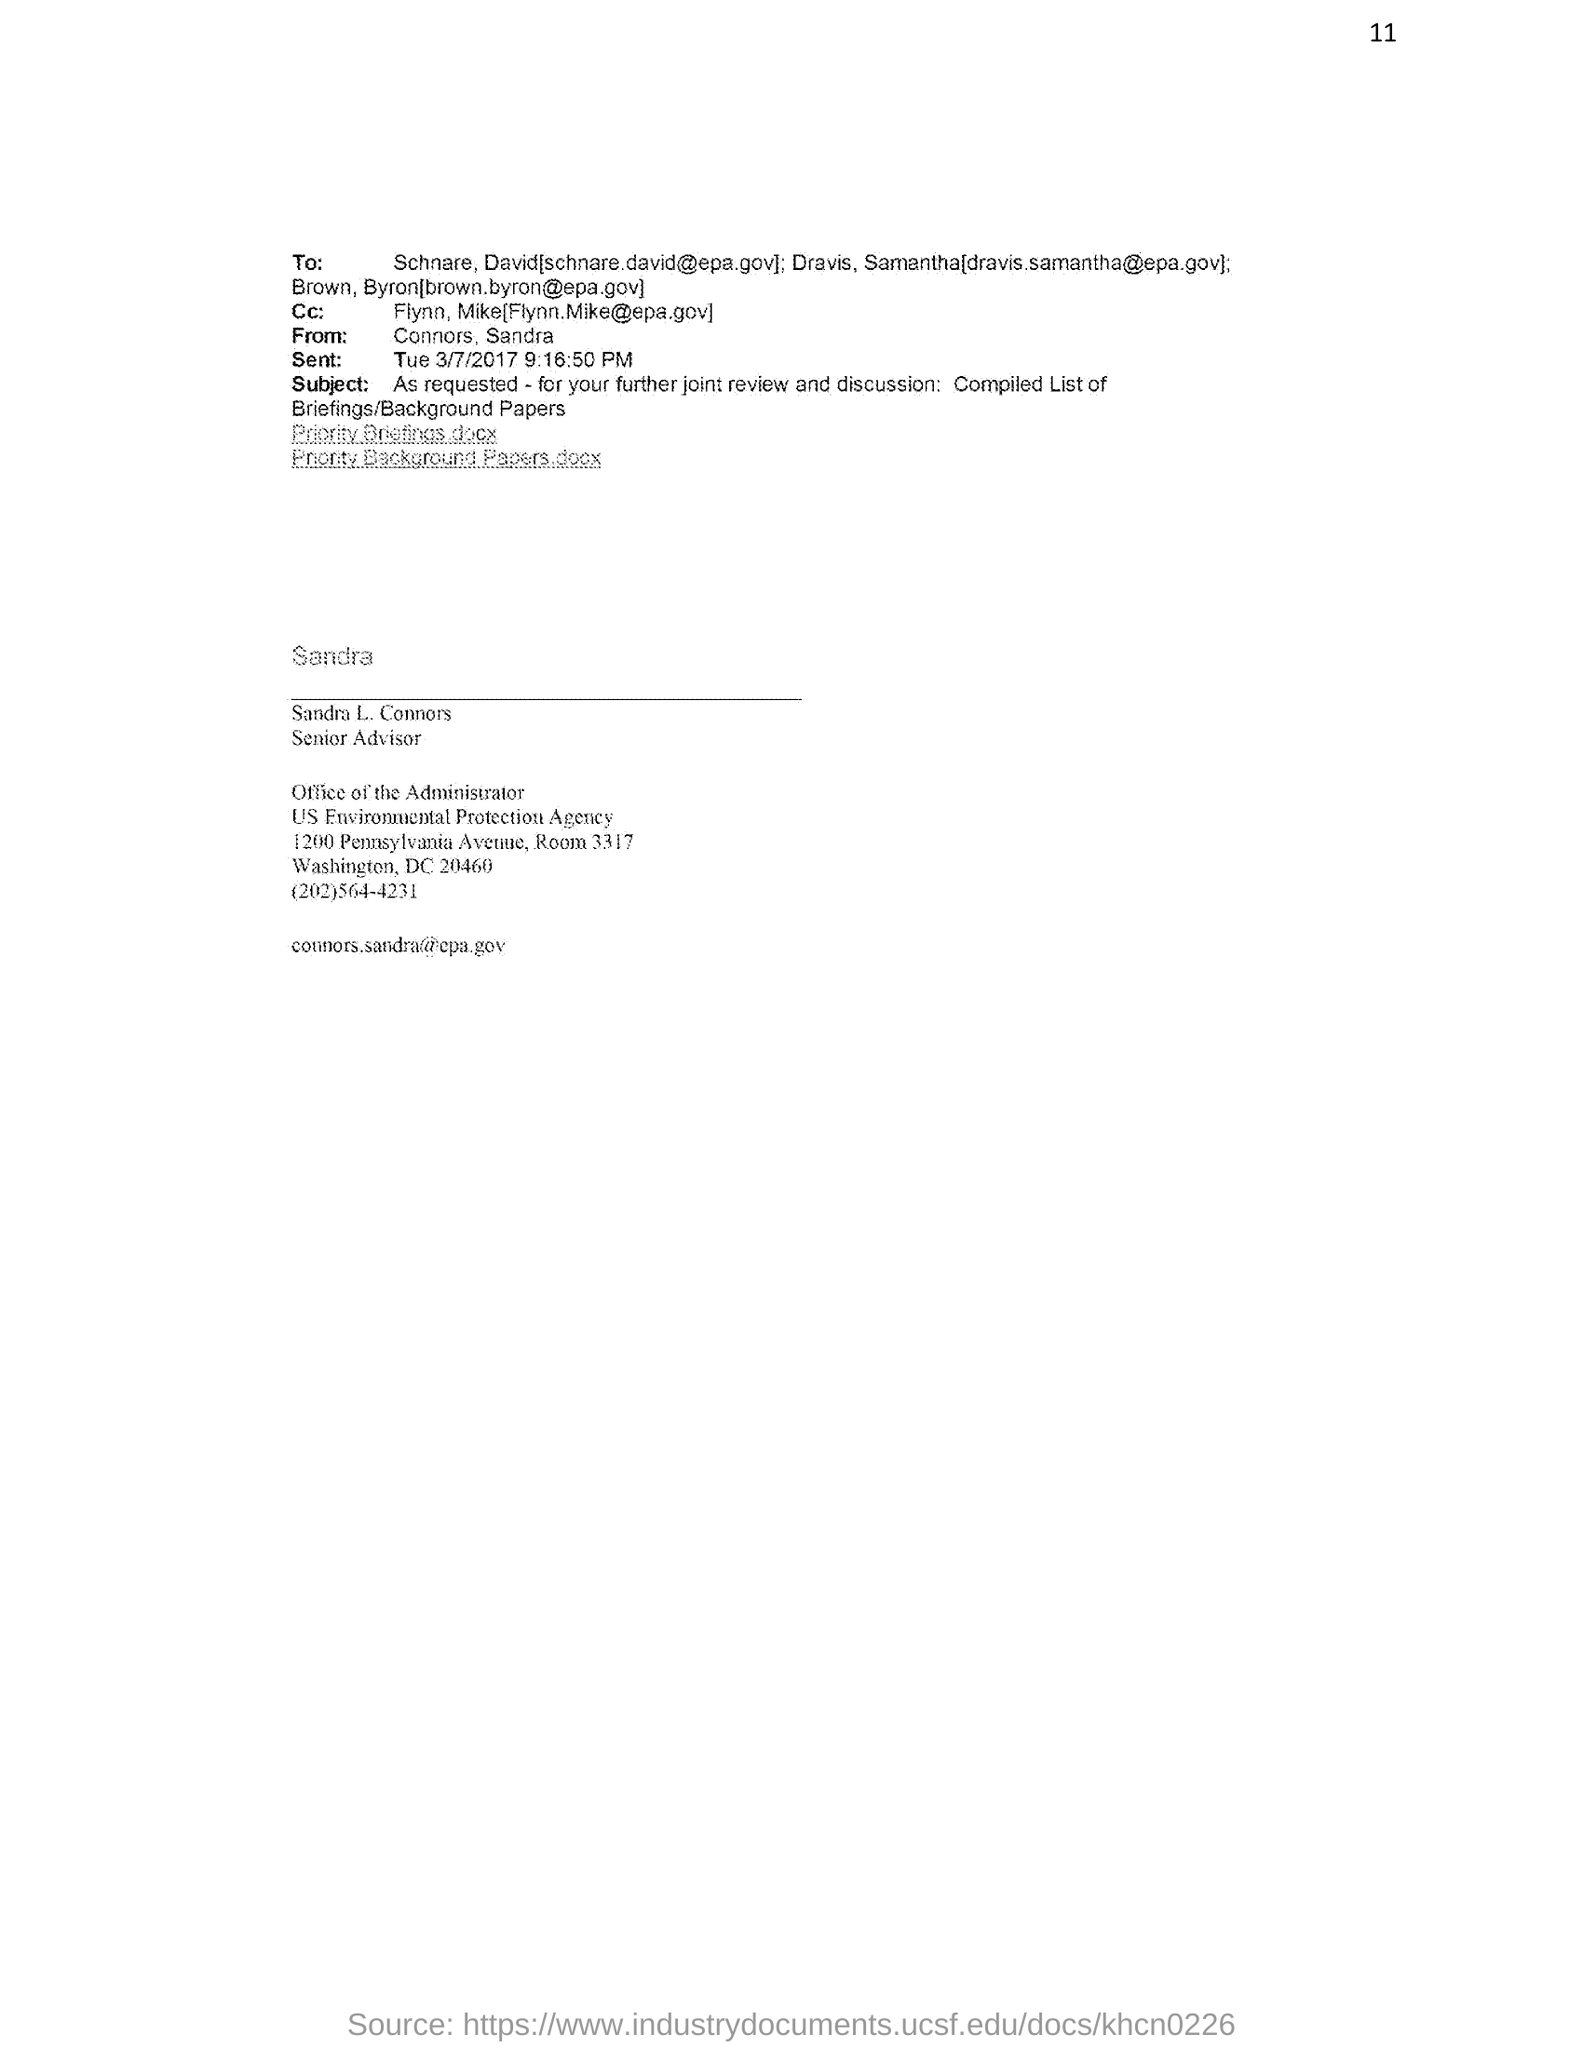What is the designation of Sandra L. Connors?
Keep it short and to the point. Senior Advisor. What is the email id of Sandra L. Connors?
Make the answer very short. Connors.sandra@epa.gov. What is the sent date and time of the email from Sandra L. Connors?
Your answer should be very brief. Tue 3/7/2017 9:16:50 PM. What is the subject of the email from Sandra L. Connors?
Ensure brevity in your answer.  As requested - for your further joint review and discussion: Compiled List of  Briefings/Background Papers. What is the contact no of Sandra L. Connors?
Provide a short and direct response. (202)564-4231. 